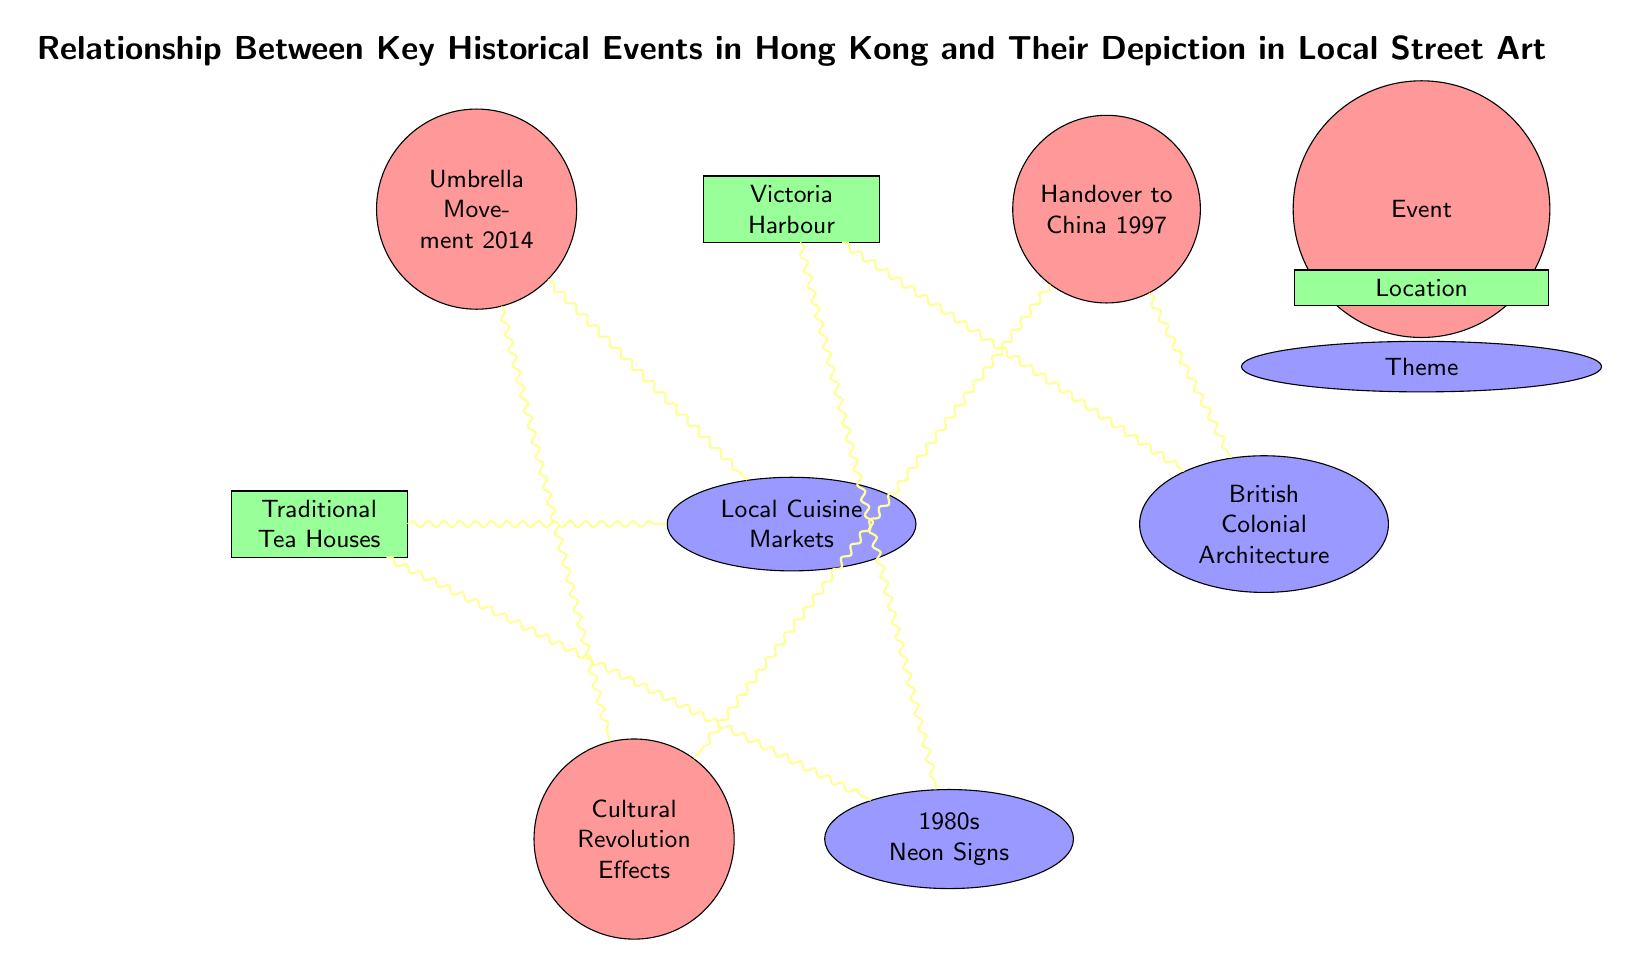What is the total number of nodes in the diagram? The diagram includes a total of 7 distinct nodes: 3 events, 2 locations, and 2 themes. By counting them, we find that the total is 7.
Answer: 7 Which theme is linked to the "Umbrella Movement 2014"? According to the diagram, there are two links from the "Umbrella Movement 2014" to "Cultural Revolution Effects" and "Local Cuisine Markets." Thus, "Local Cuisine Markets" is one connected theme.
Answer: Local Cuisine Markets How many events are related to "British Colonial Architecture"? The diagram shows 2 links connecting the "British Colonial Architecture" theme to historical events: "Handover to China 1997" and "Victoria Harbour." This indicates that 2 events are related to it.
Answer: 2 What are the two themes connected to "Traditional Tea Houses"? Looking at the diagram, "Traditional Tea Houses" has links to two themes: "Local Cuisine Markets" and "1980s Neon Signs." This information identifies both themes connected to it.
Answer: Local Cuisine Markets, 1980s Neon Signs Which location has relationships with both "1980s Neon Signs" and "British Colonial Architecture"? The node "Victoria Harbour" connects to both "1980s Neon Signs" and "British Colonial Architecture," as shown by the links originating from it. This establishes "Victoria Harbour" as the location with those connections.
Answer: Victoria Harbour What is the connection between "Cultural Revolution Effects" and both historical events? The "Cultural Revolution Effects" is connected to the "Handover to China 1997" and "Umbrella Movement 2014." Therefore, it has relationships with both of these significant historical events in the diagram.
Answer: Handover to China 1997, Umbrella Movement 2014 Which event is only directly connected to one theme, and what is that theme? The diagram indicates that "Handover to China 1997" connects exclusively to the "British Colonial Architecture" theme, as it's the only link shown directly emanating from this event.
Answer: British Colonial Architecture What type of node is "Victoria Harbour"? Reviewing the diagram, "Victoria Harbour" is categorized as a location node, as indicated by its rectangle shape and labeling.
Answer: Location 